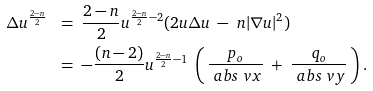Convert formula to latex. <formula><loc_0><loc_0><loc_500><loc_500>\Delta u ^ { \frac { 2 - n } { 2 } } \ & = \ \frac { 2 - n } { 2 } u ^ { \frac { 2 - n } { 2 } - 2 } ( 2 u \Delta u \ - \ n | \nabla u | ^ { 2 } ) \\ & = \ - \frac { ( n - 2 ) } { 2 } u ^ { \frac { 2 - n } { 2 } - 1 } \ \left ( \, \frac { p _ { o } } { \ a b s { \ v x } } \ + \ \frac { q _ { o } } { \ a b s { \ v y } } \, \right ) .</formula> 